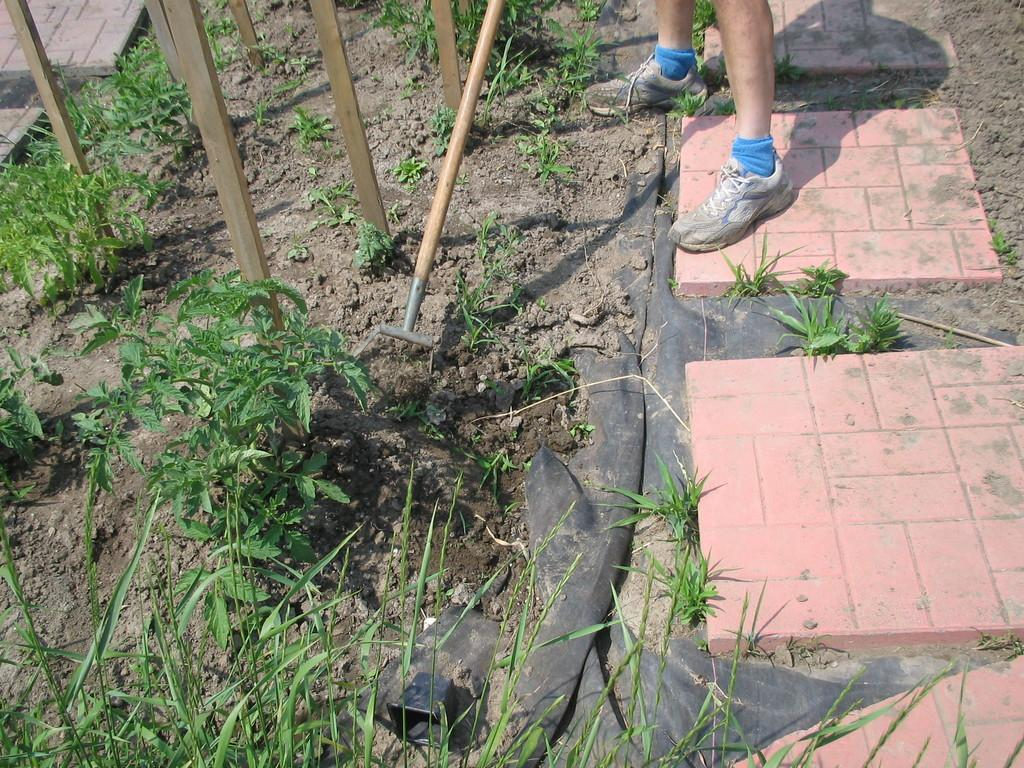What can be seen at the bottom of the image? There are legs of persons visible in the image. What type of vegetation is present in the image? There is grass in the image. What material are the poles made of in the image? There are wooden poles in the image. What else can be found on the ground in the image? There are other objects on the ground in the image. How many thoughts can be seen in the image? There are no thoughts visible in the image, as thoughts are not something that can be seen. Can you describe the person in the image? There is no person present in the image; only legs of persons are visible. 